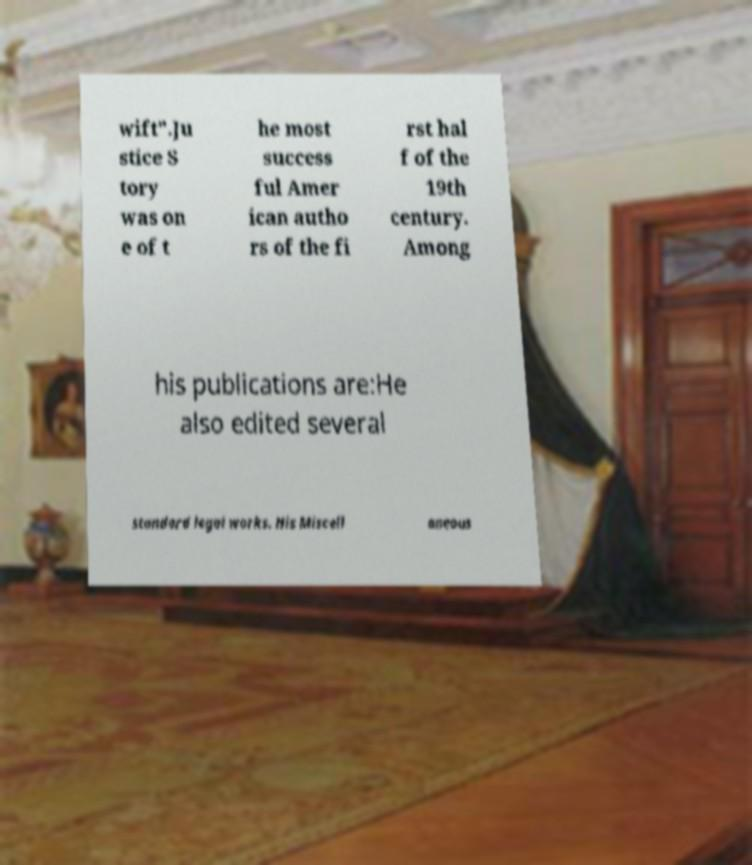Please identify and transcribe the text found in this image. wift".Ju stice S tory was on e of t he most success ful Amer ican autho rs of the fi rst hal f of the 19th century. Among his publications are:He also edited several standard legal works. His Miscell aneous 